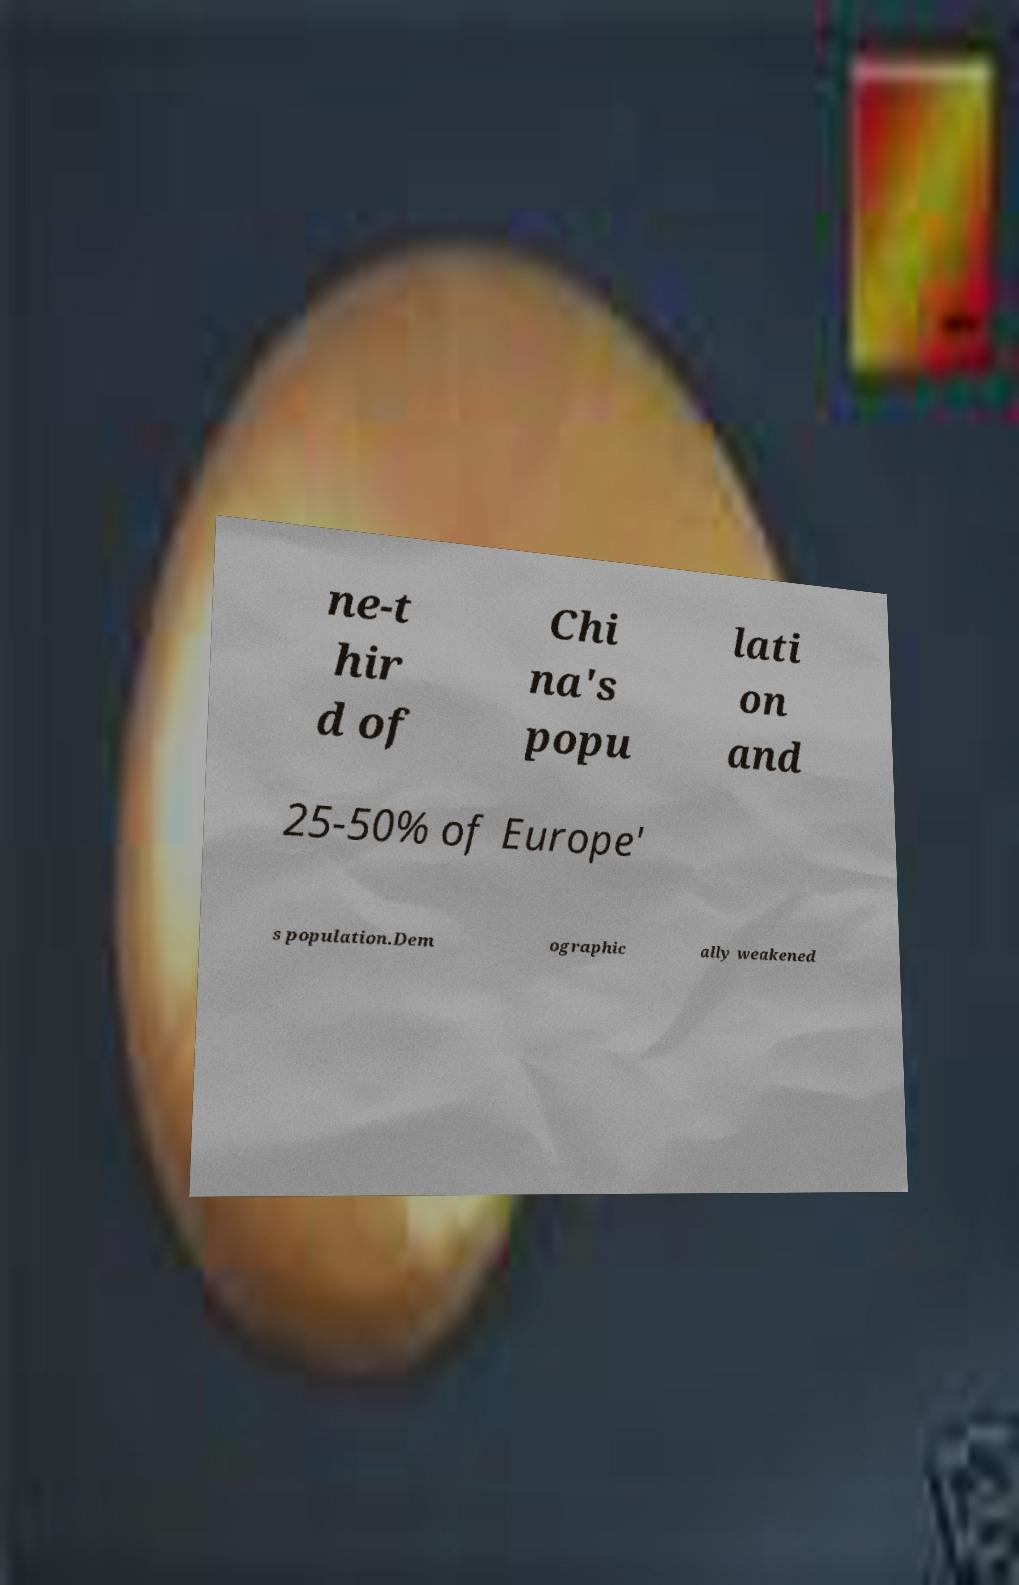There's text embedded in this image that I need extracted. Can you transcribe it verbatim? ne-t hir d of Chi na's popu lati on and 25-50% of Europe' s population.Dem ographic ally weakened 